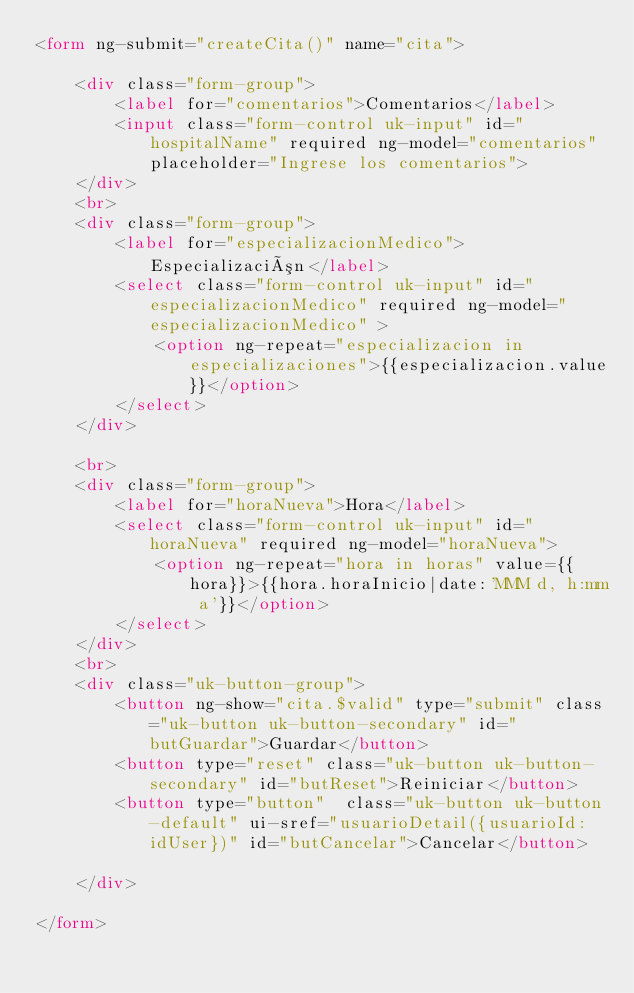<code> <loc_0><loc_0><loc_500><loc_500><_HTML_><form ng-submit="createCita()" name="cita">

    <div class="form-group">
        <label for="comentarios">Comentarios</label>
        <input class="form-control uk-input" id="hospitalName" required ng-model="comentarios" placeholder="Ingrese los comentarios">
    </div>
    <br>
    <div class="form-group">
        <label for="especializacionMedico">Especialización</label>
        <select class="form-control uk-input" id="especializacionMedico" required ng-model="especializacionMedico" >
            <option ng-repeat="especializacion in especializaciones">{{especializacion.value}}</option>
        </select>
    </div>
    
    <br>
    <div class="form-group">
        <label for="horaNueva">Hora</label>
        <select class="form-control uk-input" id="horaNueva" required ng-model="horaNueva">
            <option ng-repeat="hora in horas" value={{hora}}>{{hora.horaInicio|date:'MMM d, h:mm a'}}</option>
        </select>
    </div>
    <br>
    <div class="uk-button-group">
        <button ng-show="cita.$valid" type="submit" class="uk-button uk-button-secondary" id="butGuardar">Guardar</button>
        <button type="reset" class="uk-button uk-button-secondary" id="butReset">Reiniciar</button>
        <button type="button"  class="uk-button uk-button-default" ui-sref="usuarioDetail({usuarioId:idUser})" id="butCancelar">Cancelar</button>
        
    </div>

</form>
</code> 